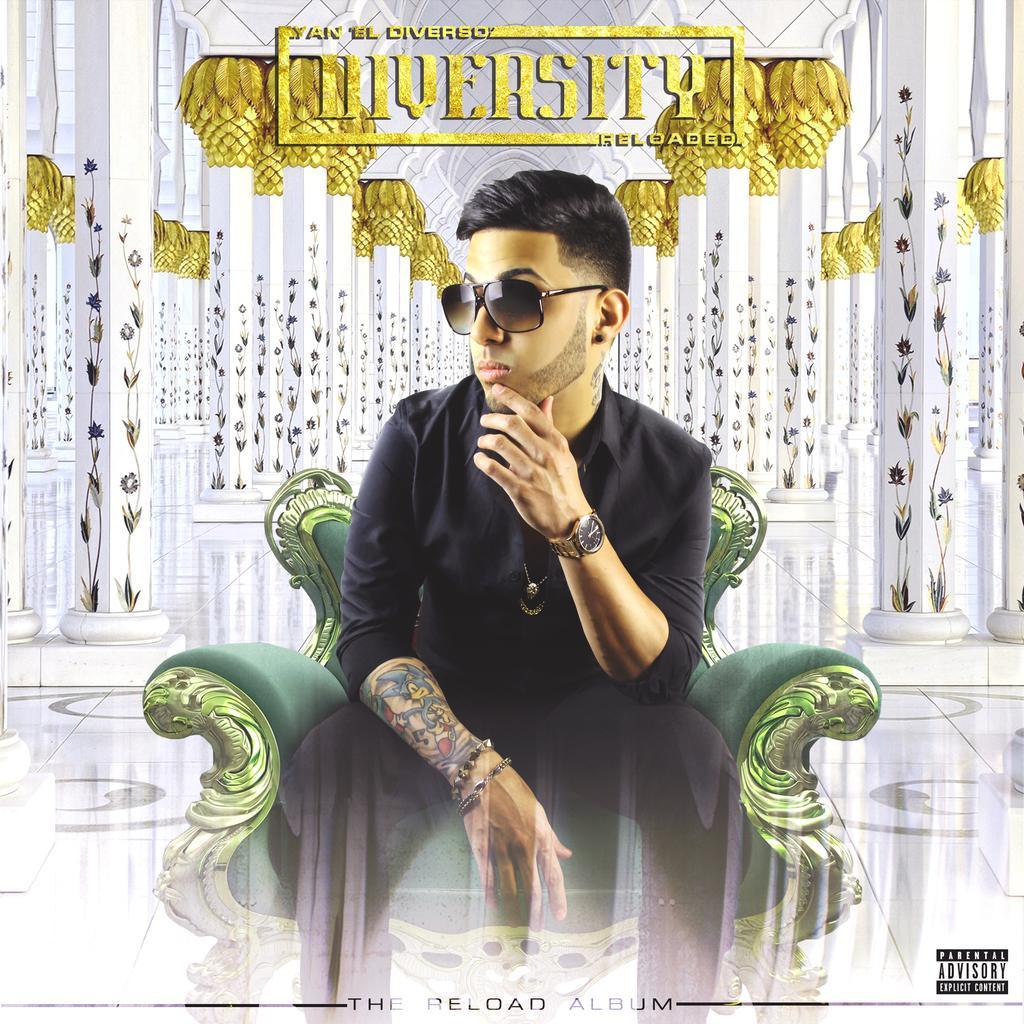In one or two sentences, can you explain what this image depicts? In this picture, we can see a poster of person sitting in a chair, we can see some pillars, floor and we can see some label on top and we can see a watermark in the bottom right corner. 